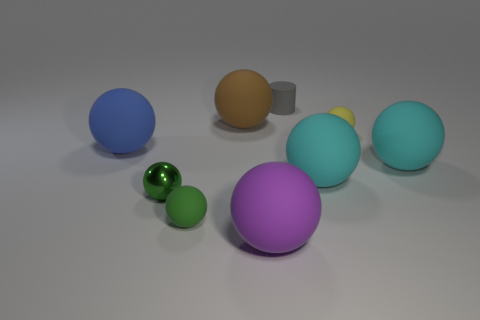Is the material of the large thing that is left of the green shiny object the same as the green object behind the small green rubber thing?
Your answer should be compact. No. How many other objects are the same material as the purple ball?
Provide a short and direct response. 7. Are there more big objects on the right side of the small green matte object than brown things that are behind the tiny gray cylinder?
Give a very brief answer. Yes. There is a brown thing; how many brown balls are in front of it?
Provide a short and direct response. 0. Is the material of the large purple object the same as the tiny sphere that is to the right of the large purple matte ball?
Your answer should be compact. Yes. Is there anything else that is the same shape as the small gray object?
Offer a very short reply. No. Are there any brown objects right of the matte object in front of the small green rubber ball?
Provide a succinct answer. No. How many objects are both right of the big purple matte ball and behind the tiny yellow rubber thing?
Make the answer very short. 1. What shape is the matte object that is behind the brown ball?
Your response must be concise. Cylinder. How many objects have the same size as the blue ball?
Offer a terse response. 4. 